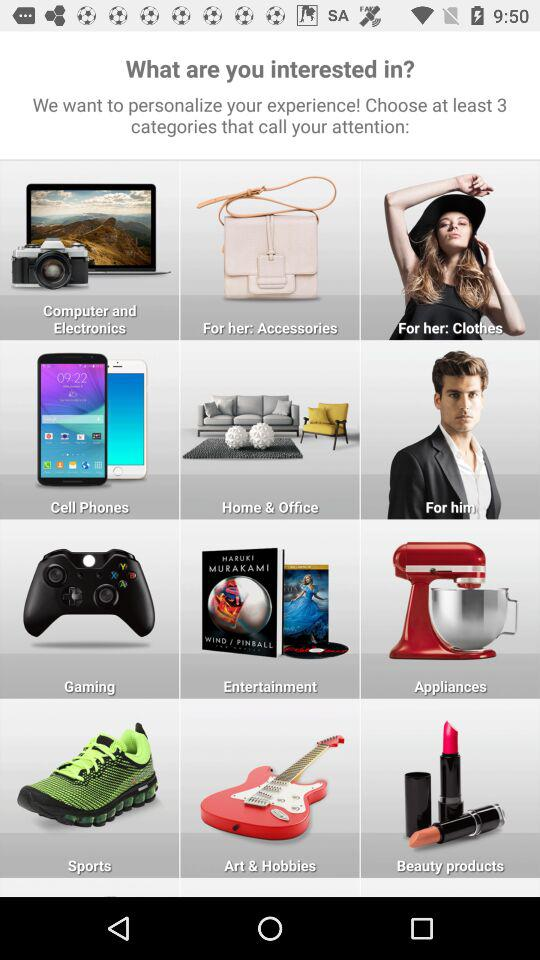How many categories can we choose? You can choose at least 3 categories. 